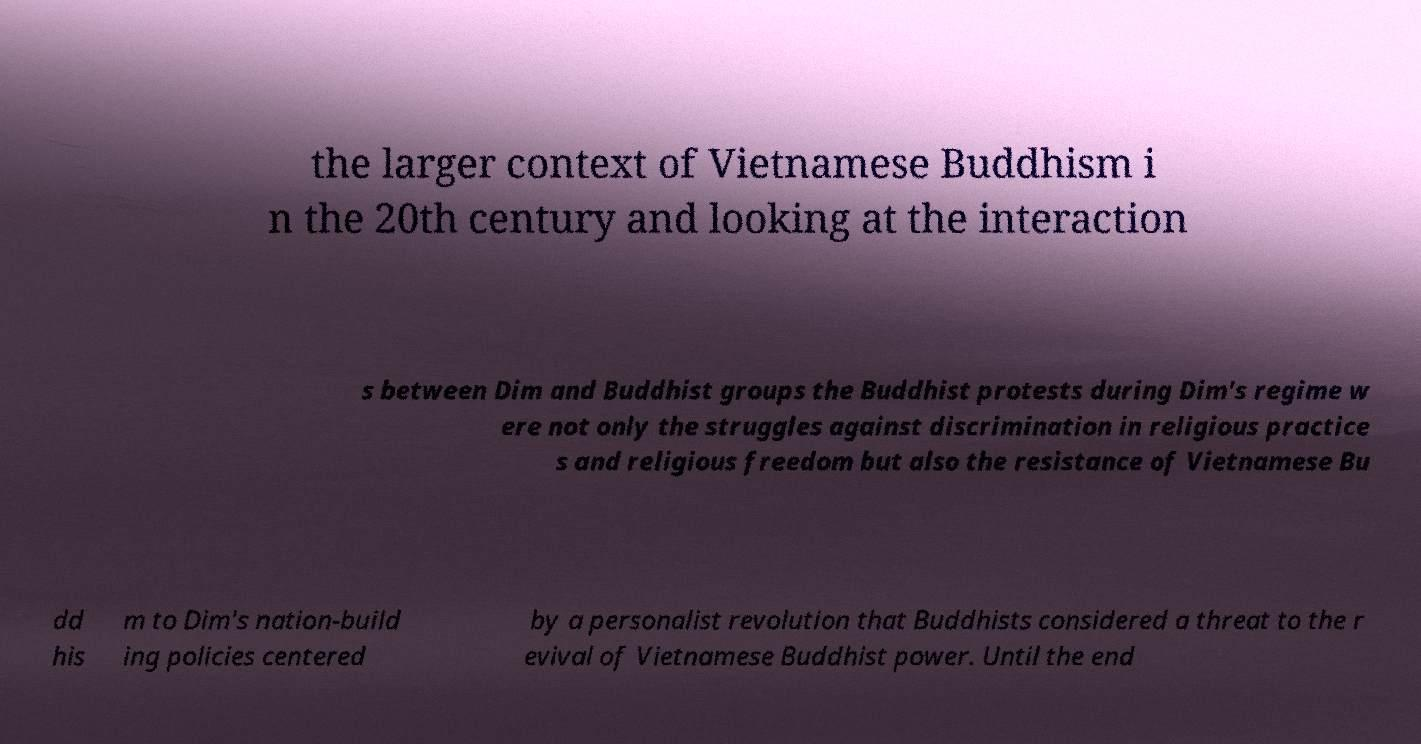Please identify and transcribe the text found in this image. the larger context of Vietnamese Buddhism i n the 20th century and looking at the interaction s between Dim and Buddhist groups the Buddhist protests during Dim's regime w ere not only the struggles against discrimination in religious practice s and religious freedom but also the resistance of Vietnamese Bu dd his m to Dim's nation-build ing policies centered by a personalist revolution that Buddhists considered a threat to the r evival of Vietnamese Buddhist power. Until the end 